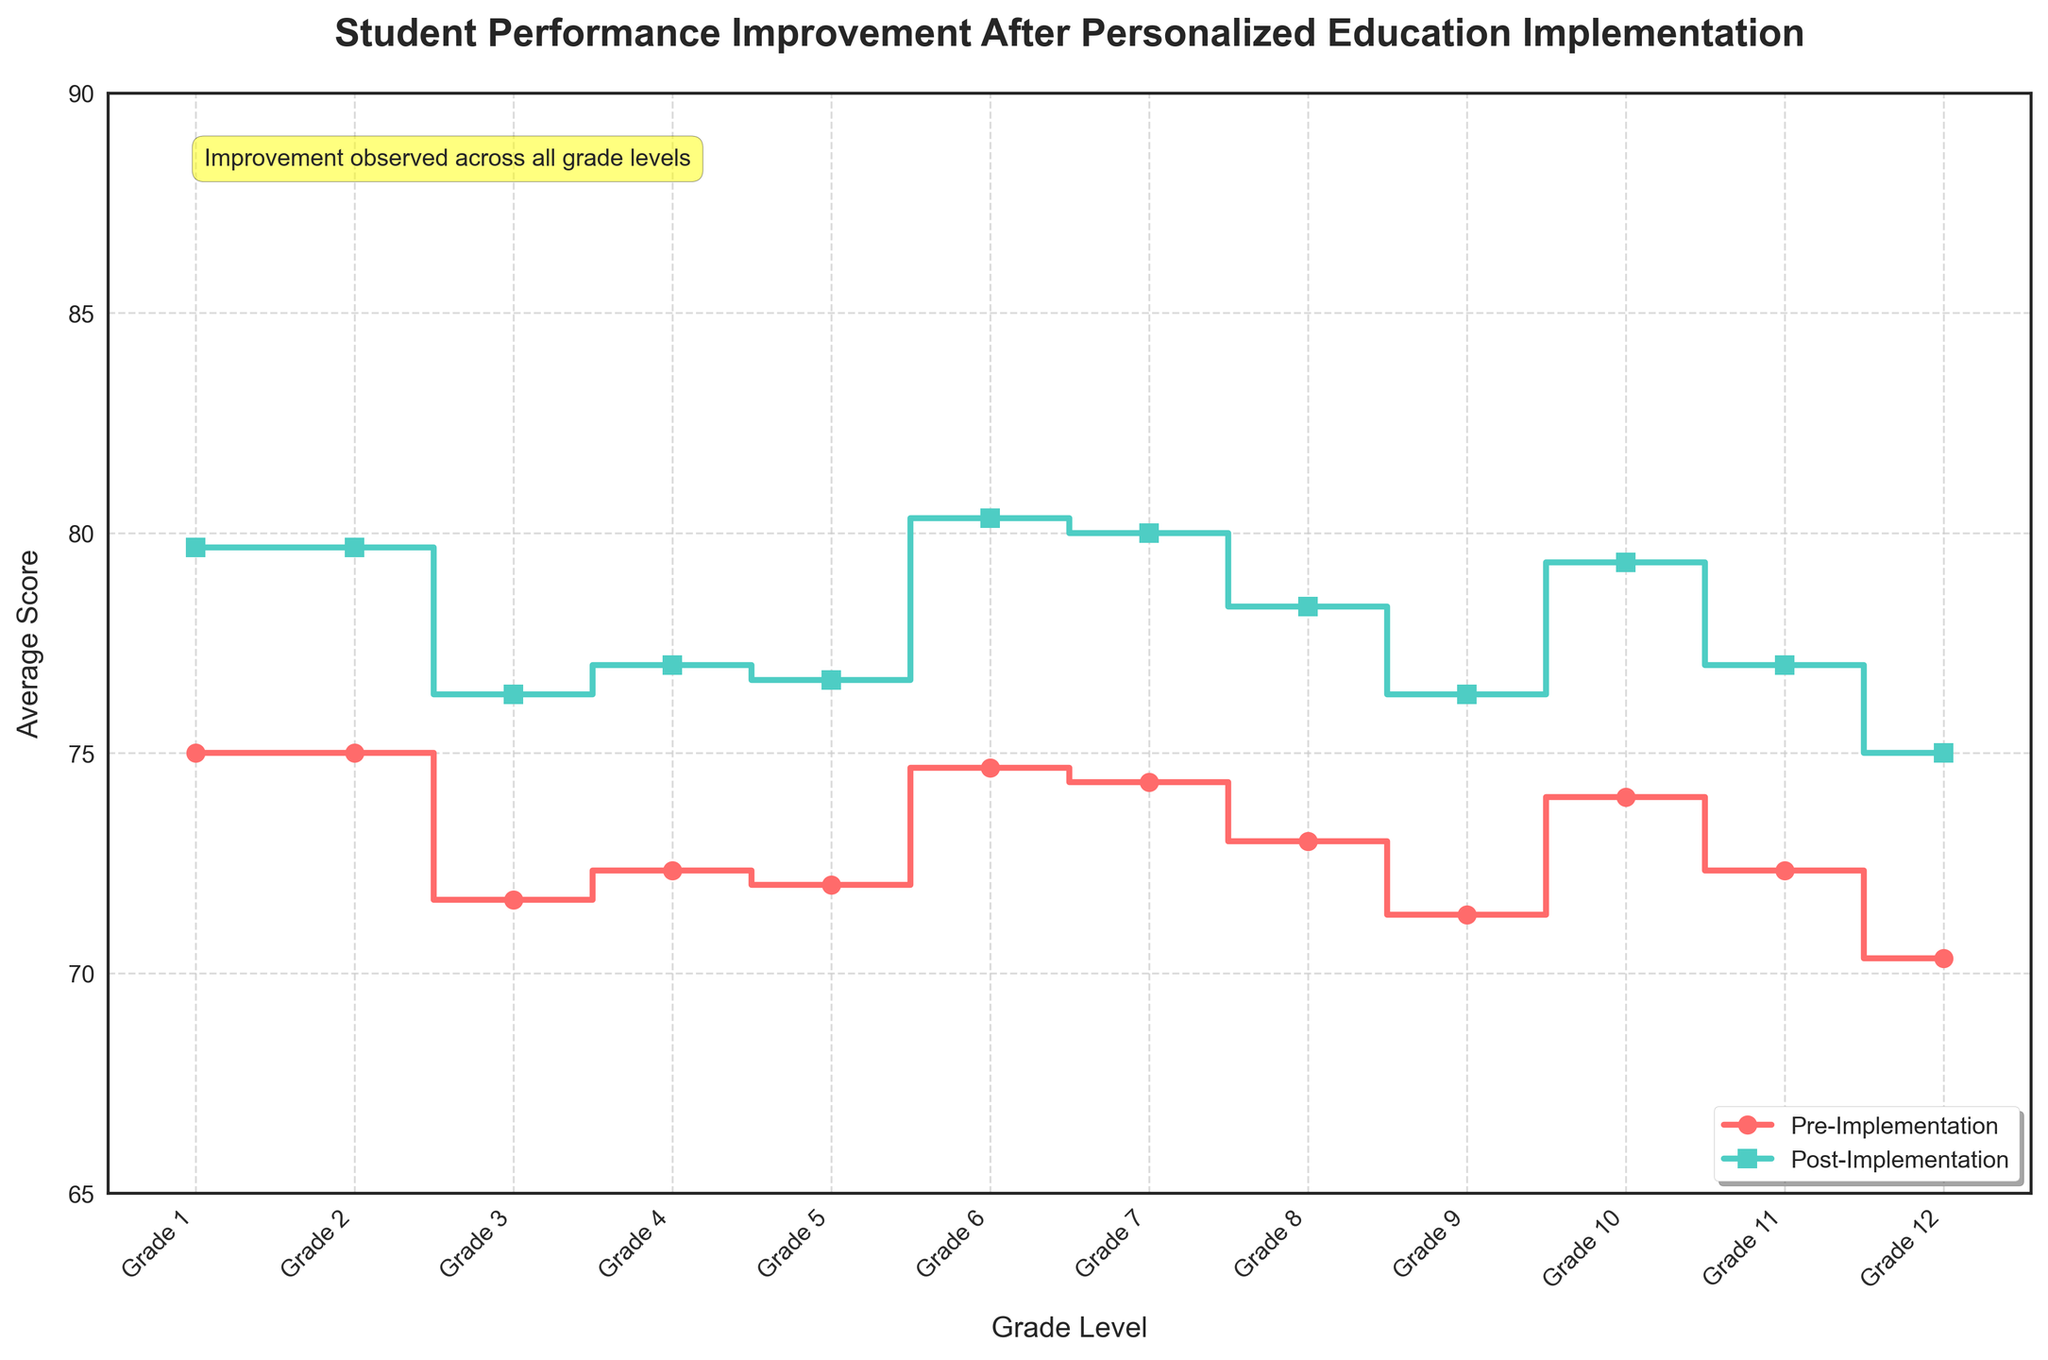What is the title of the figure? The title is located at the top of the figure. It states what the plot is about and can be read directly from the top of the image.
Answer: Student Performance Improvement After Personalized Education Implementation What are the colors used to differentiate the pre-implementation and post-implementation scores? Observing the two steps in the plot, the pre-implementation scores are indicated using a line and markers of a specific color, while the post-implementation scores use a different color. This is often accompanied by a legend.
Answer: Red and teal What is the range of the y-axis in the figure? Examining the y-axis, which shows the average scores, you can see the range marked from the lowest to the highest score.
Answer: 65 to 90 On average, which grade showed the highest improvement in scores? To find this, you need to compare both the pre- and post-implementation scores for each grade, then determine which grade had the largest increase in their scores.
Answer: Grade 10 What trend can be seen in student performance from Grade 1 to Grade 12 after implementing personalized education programs? Observing the post-implementation score line from Grade 1 to Grade 12, one can see whether scores generally increase, decrease, or stay consistent.
Answer: Scores generally increase How does the average score improvement for Grade 8 compare to that of Grade 9? Look at the average improvement by comparing the pre- and post-implementation scores for Grades 8 and 9; calculate which one has a larger difference.
Answer: Grade 8 has a slightly higher improvement Is there any grade where the pre-implementation score and post-implementation score are the same? This would be indicated if there are overlapping points for any grade in both the pre- and post-implementation scores. By examining each plot point, any grade with identical scores will be observed.
Answer: No What information is displayed in the annotation box on the plot? There's a text box in the figure with specific observations related to the plot. Read the contents of this box.
Answer: Improvement observed across all grade levels Does the figure include a legend, and where is it located? Look at the figure for keys and labels that show what the different lines and markers represent. Often positioned at one of the corners of the plot.
Answer: Yes, lower right What can be inferred about the performance of students in Grade 5 before and after the implementation of personalized education programs? Compare the pre- and post-implementation average scores for Grade 5 by following the lines that represent these scores and noting their exact position.
Answer: There is an improvement from an average score of 72 to 76 